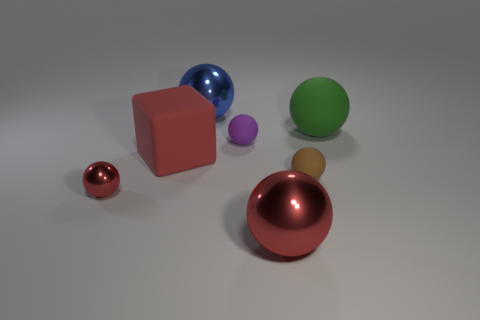Can you describe the physical textures of the objects shown here? Certainly! The image displays objects with at least two distinctive textures. The blocks, including the large pink one, exhibit a matte finish which diffuses light and provides a solid, non-reflective appearance. In contrast, the colored balls have a smooth, metallic texture, characterized by shiny surfaces that reflect the surrounding light, creating clear and defined highlights and contributing to a lustrous visual quality. 